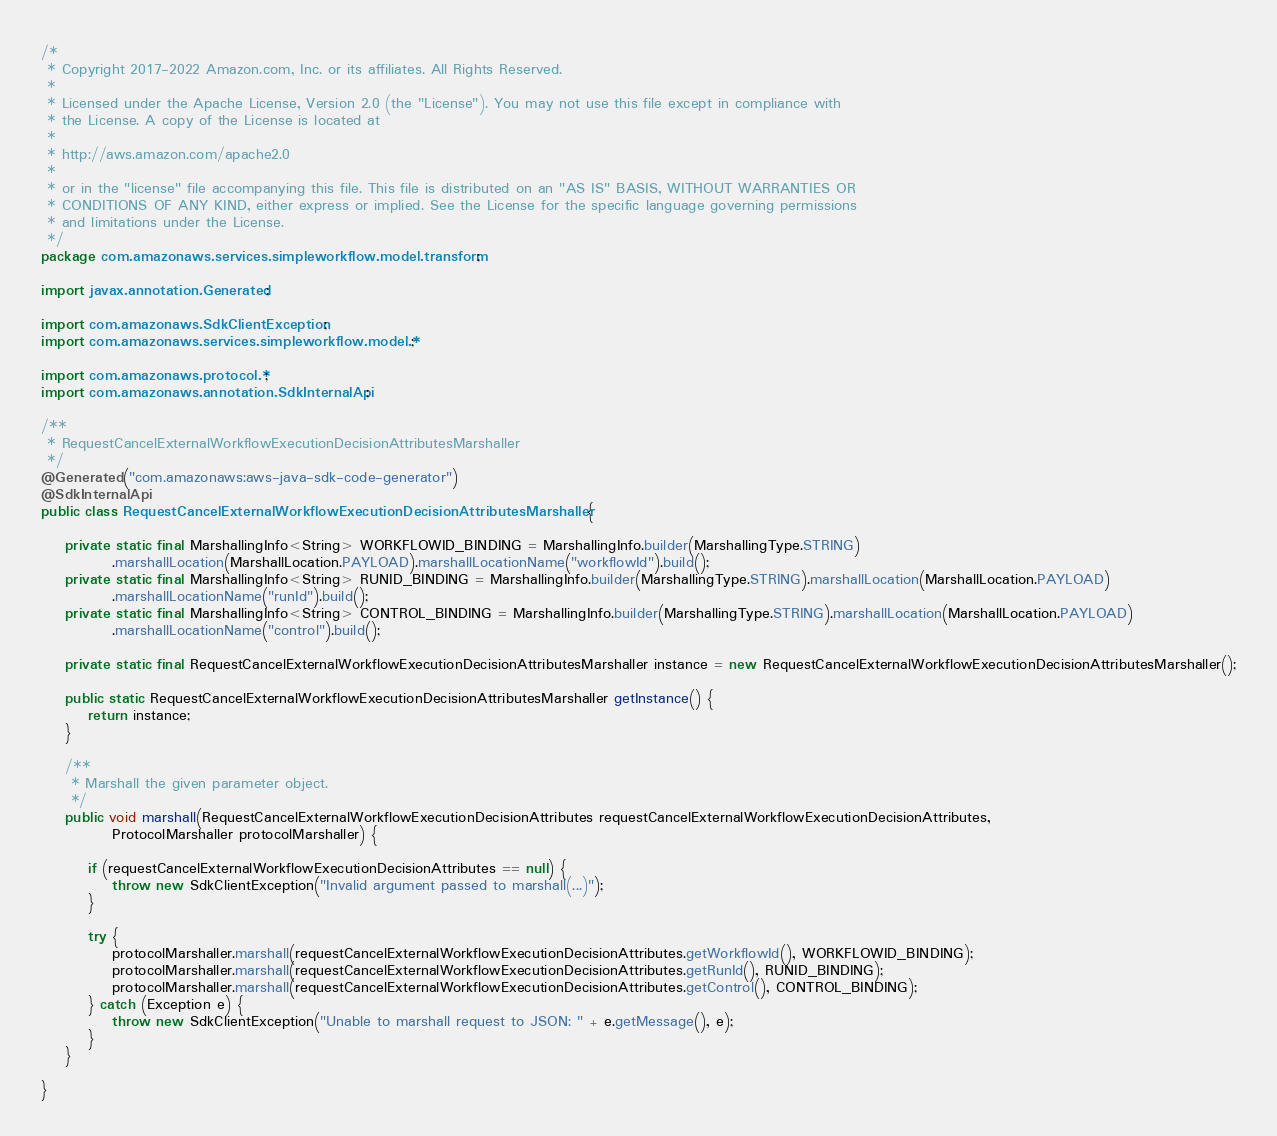Convert code to text. <code><loc_0><loc_0><loc_500><loc_500><_Java_>/*
 * Copyright 2017-2022 Amazon.com, Inc. or its affiliates. All Rights Reserved.
 * 
 * Licensed under the Apache License, Version 2.0 (the "License"). You may not use this file except in compliance with
 * the License. A copy of the License is located at
 * 
 * http://aws.amazon.com/apache2.0
 * 
 * or in the "license" file accompanying this file. This file is distributed on an "AS IS" BASIS, WITHOUT WARRANTIES OR
 * CONDITIONS OF ANY KIND, either express or implied. See the License for the specific language governing permissions
 * and limitations under the License.
 */
package com.amazonaws.services.simpleworkflow.model.transform;

import javax.annotation.Generated;

import com.amazonaws.SdkClientException;
import com.amazonaws.services.simpleworkflow.model.*;

import com.amazonaws.protocol.*;
import com.amazonaws.annotation.SdkInternalApi;

/**
 * RequestCancelExternalWorkflowExecutionDecisionAttributesMarshaller
 */
@Generated("com.amazonaws:aws-java-sdk-code-generator")
@SdkInternalApi
public class RequestCancelExternalWorkflowExecutionDecisionAttributesMarshaller {

    private static final MarshallingInfo<String> WORKFLOWID_BINDING = MarshallingInfo.builder(MarshallingType.STRING)
            .marshallLocation(MarshallLocation.PAYLOAD).marshallLocationName("workflowId").build();
    private static final MarshallingInfo<String> RUNID_BINDING = MarshallingInfo.builder(MarshallingType.STRING).marshallLocation(MarshallLocation.PAYLOAD)
            .marshallLocationName("runId").build();
    private static final MarshallingInfo<String> CONTROL_BINDING = MarshallingInfo.builder(MarshallingType.STRING).marshallLocation(MarshallLocation.PAYLOAD)
            .marshallLocationName("control").build();

    private static final RequestCancelExternalWorkflowExecutionDecisionAttributesMarshaller instance = new RequestCancelExternalWorkflowExecutionDecisionAttributesMarshaller();

    public static RequestCancelExternalWorkflowExecutionDecisionAttributesMarshaller getInstance() {
        return instance;
    }

    /**
     * Marshall the given parameter object.
     */
    public void marshall(RequestCancelExternalWorkflowExecutionDecisionAttributes requestCancelExternalWorkflowExecutionDecisionAttributes,
            ProtocolMarshaller protocolMarshaller) {

        if (requestCancelExternalWorkflowExecutionDecisionAttributes == null) {
            throw new SdkClientException("Invalid argument passed to marshall(...)");
        }

        try {
            protocolMarshaller.marshall(requestCancelExternalWorkflowExecutionDecisionAttributes.getWorkflowId(), WORKFLOWID_BINDING);
            protocolMarshaller.marshall(requestCancelExternalWorkflowExecutionDecisionAttributes.getRunId(), RUNID_BINDING);
            protocolMarshaller.marshall(requestCancelExternalWorkflowExecutionDecisionAttributes.getControl(), CONTROL_BINDING);
        } catch (Exception e) {
            throw new SdkClientException("Unable to marshall request to JSON: " + e.getMessage(), e);
        }
    }

}
</code> 